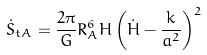<formula> <loc_0><loc_0><loc_500><loc_500>\dot { S } _ { t A } = \frac { 2 \pi } { G } R _ { A } ^ { 6 } H \left ( \dot { H } - \frac { k } { a ^ { 2 } } \right ) ^ { 2 }</formula> 